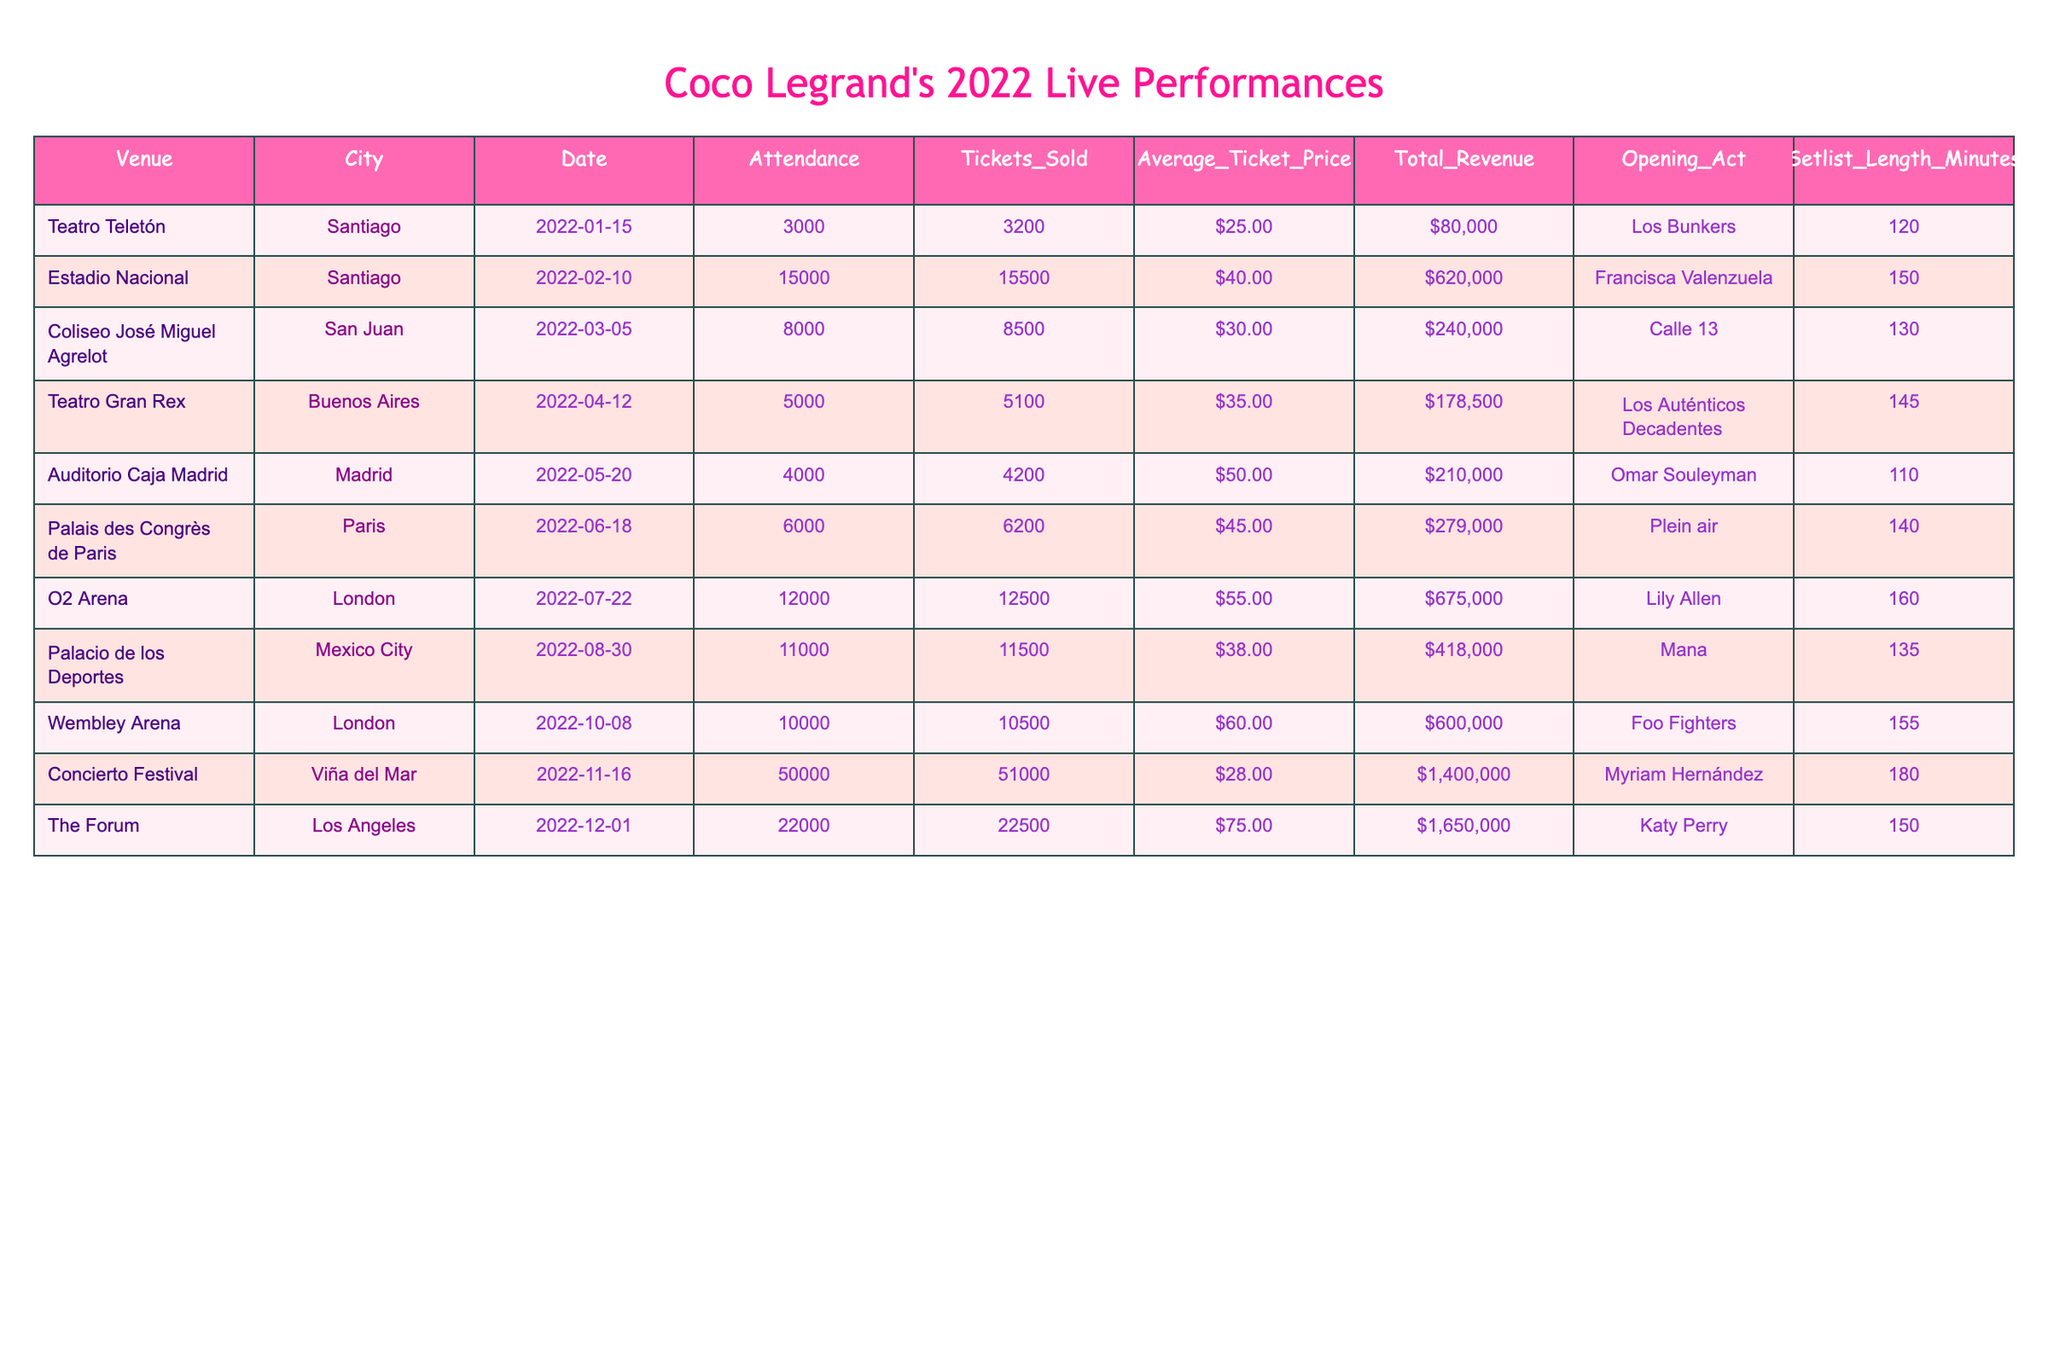What was the attendance at the Teatro Teletón performance? The table lists the attendance at the Teatro Teletón as 3,000.
Answer: 3000 How much total revenue was generated from the concert in Viña del Mar? The total revenue from the Concierto Festival in Viña del Mar is listed as $1,400,000.
Answer: $1,400,000 Which city hosted the concert with the highest ticket sales? The concert in Viña del Mar had 51,000 tickets sold, which is the highest compared to other venues listed.
Answer: Viña del Mar What was the average ticket price for the concert at the O2 Arena? The average ticket price at the O2 Arena is shown as $55.00.
Answer: $55.00 How many more tickets were sold at the Palacio de los Deportes compared to the Teatro Gran Rex? Tickets sold at the Palacio de los Deportes were 11,500, while at Teatro Gran Rex, they were 5,100. The difference is 11,500 - 5,100 = 6,400.
Answer: 6400 Was the average ticket price higher at the Coliseo José Miguel Agrelot compared to the Teatro Teletón? The average ticket price at Coliseo José Miguel Agrelot was $30.00, while at Teatro Teletón, it was $25.00. Since $30.00 is greater than $25.00, the statement is true.
Answer: Yes What is the total attended audience across all venues listed? To find the total attendance, sum the attendances from all venues: 3000 + 15000 + 8000 + 5000 + 4000 + 6000 + 12000 + 11000 + 10000 + 50000 + 22000 = 1,07,000.
Answer: 107000 Which performance had the longest setlist length, and how many minutes was it? The concert in Viña del Mar had a setlist length of 180 minutes, which is the longest according to the table.
Answer: 180 What was the total revenue from the concerts held in London? There were two concerts in London: one at Wembley Arena with a revenue of $600,000 and one at the O2 Arena with $675,000. Their total is 600,000 + 675,000 = $1,275,000.
Answer: $1,275,000 Was the opening act in Paris more or less popular compared to the act in Madrid based on revenue? The opening act in Paris (Plein air) generated $279,000, while Omar Souleyman in Madrid generated $210,000. Since $279,000 is greater than $210,000, the act in Paris was more popular in terms of revenue.
Answer: More popular 